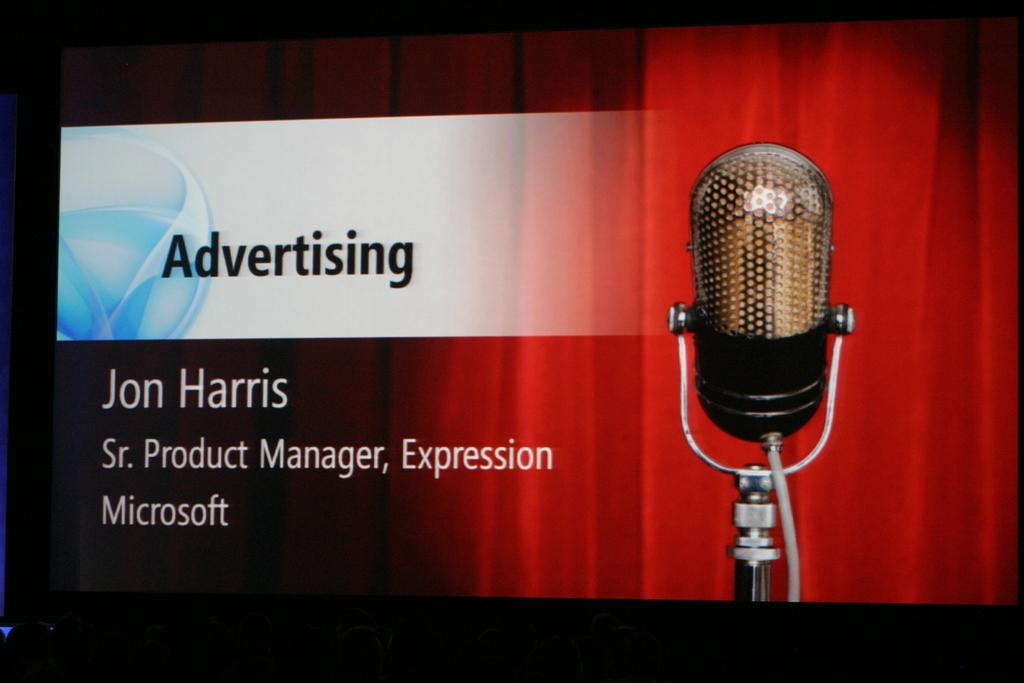What is the main object in the image? There is a screen in the image. What is shown on the screen? The screen displays an image of a microphone. Are there any words on the screen? Yes, there are words on the screen. Can you see any wings on the microphone in the image? There are no wings visible on the microphone in the image. What type of loaf is being toasted in the image? There is no loaf or toasting activity present in the image. 